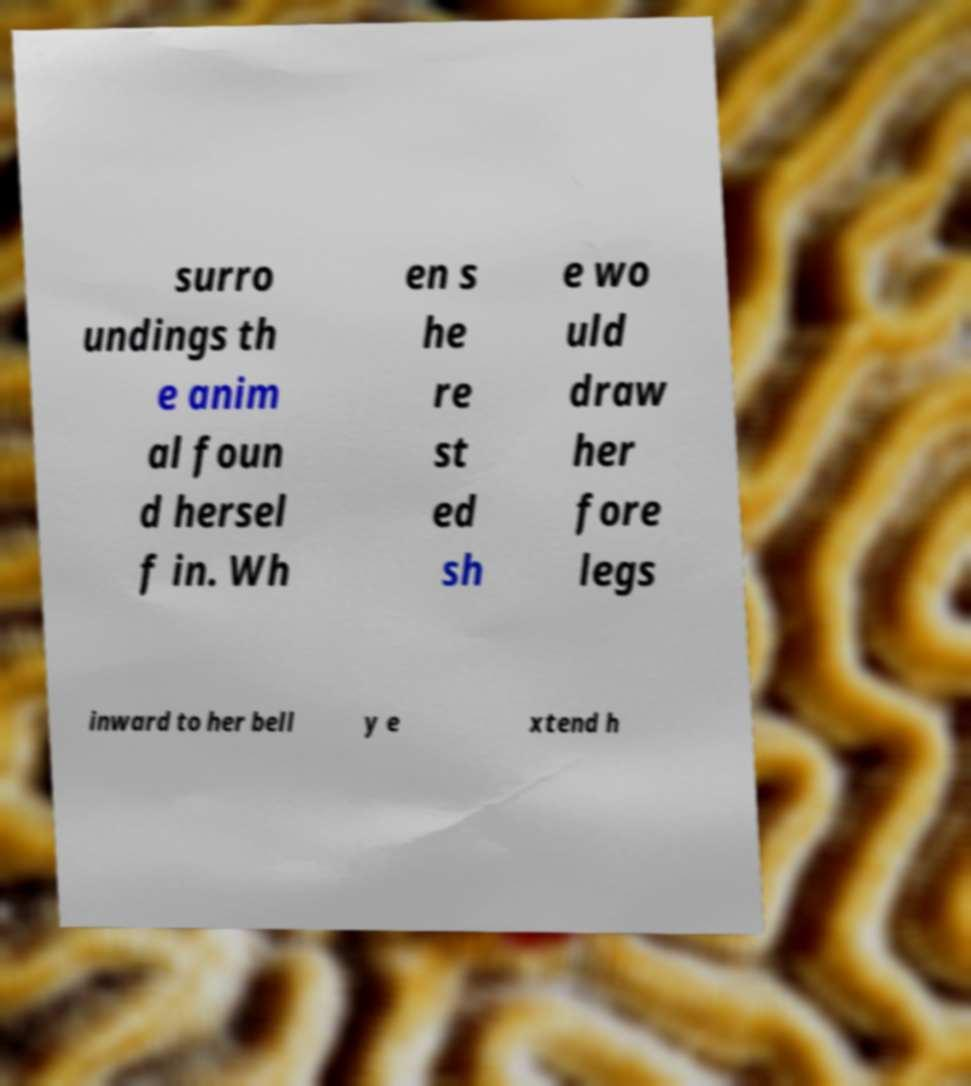Can you accurately transcribe the text from the provided image for me? surro undings th e anim al foun d hersel f in. Wh en s he re st ed sh e wo uld draw her fore legs inward to her bell y e xtend h 